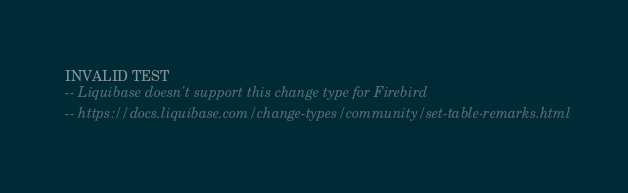<code> <loc_0><loc_0><loc_500><loc_500><_SQL_>INVALID TEST
-- Liquibase doesn't support this change type for Firebird
-- https://docs.liquibase.com/change-types/community/set-table-remarks.html</code> 